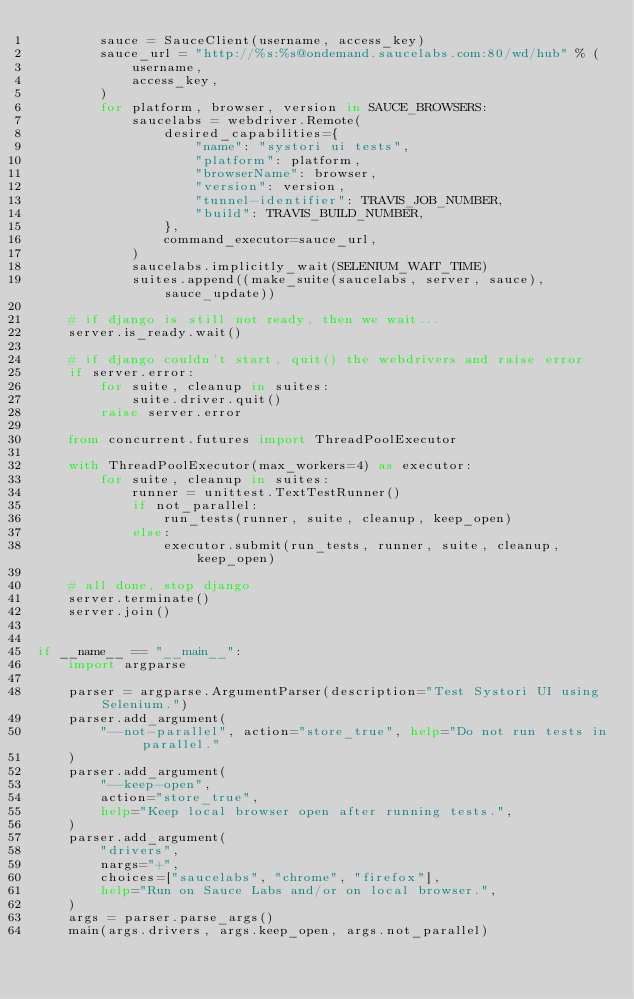<code> <loc_0><loc_0><loc_500><loc_500><_Python_>        sauce = SauceClient(username, access_key)
        sauce_url = "http://%s:%s@ondemand.saucelabs.com:80/wd/hub" % (
            username,
            access_key,
        )
        for platform, browser, version in SAUCE_BROWSERS:
            saucelabs = webdriver.Remote(
                desired_capabilities={
                    "name": "systori ui tests",
                    "platform": platform,
                    "browserName": browser,
                    "version": version,
                    "tunnel-identifier": TRAVIS_JOB_NUMBER,
                    "build": TRAVIS_BUILD_NUMBER,
                },
                command_executor=sauce_url,
            )
            saucelabs.implicitly_wait(SELENIUM_WAIT_TIME)
            suites.append((make_suite(saucelabs, server, sauce), sauce_update))

    # if django is still not ready, then we wait...
    server.is_ready.wait()

    # if django couldn't start, quit() the webdrivers and raise error
    if server.error:
        for suite, cleanup in suites:
            suite.driver.quit()
        raise server.error

    from concurrent.futures import ThreadPoolExecutor

    with ThreadPoolExecutor(max_workers=4) as executor:
        for suite, cleanup in suites:
            runner = unittest.TextTestRunner()
            if not_parallel:
                run_tests(runner, suite, cleanup, keep_open)
            else:
                executor.submit(run_tests, runner, suite, cleanup, keep_open)

    # all done, stop django
    server.terminate()
    server.join()


if __name__ == "__main__":
    import argparse

    parser = argparse.ArgumentParser(description="Test Systori UI using Selenium.")
    parser.add_argument(
        "--not-parallel", action="store_true", help="Do not run tests in parallel."
    )
    parser.add_argument(
        "--keep-open",
        action="store_true",
        help="Keep local browser open after running tests.",
    )
    parser.add_argument(
        "drivers",
        nargs="+",
        choices=["saucelabs", "chrome", "firefox"],
        help="Run on Sauce Labs and/or on local browser.",
    )
    args = parser.parse_args()
    main(args.drivers, args.keep_open, args.not_parallel)
</code> 